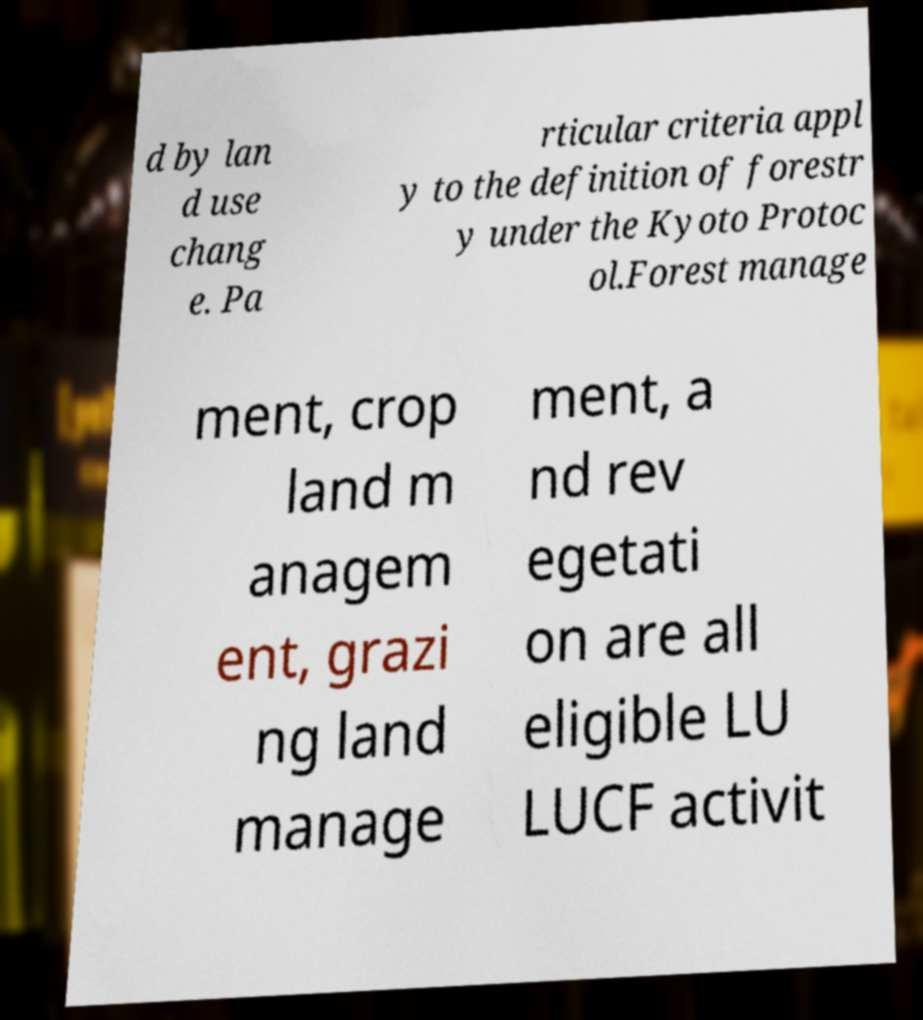There's text embedded in this image that I need extracted. Can you transcribe it verbatim? d by lan d use chang e. Pa rticular criteria appl y to the definition of forestr y under the Kyoto Protoc ol.Forest manage ment, crop land m anagem ent, grazi ng land manage ment, a nd rev egetati on are all eligible LU LUCF activit 